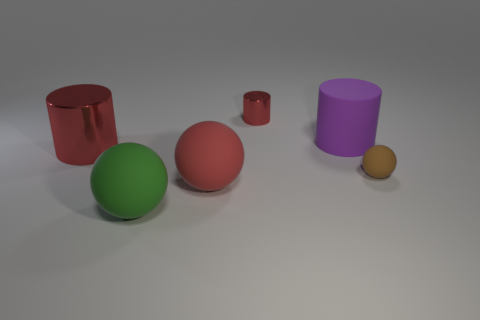How big is the matte cylinder?
Your answer should be compact. Large. How many things are either small blue metal cylinders or rubber objects?
Your response must be concise. 4. Are the big red thing that is in front of the big red metal cylinder and the sphere right of the big matte cylinder made of the same material?
Keep it short and to the point. Yes. There is a big cylinder that is the same material as the small cylinder; what color is it?
Make the answer very short. Red. What number of other balls have the same size as the green matte sphere?
Your answer should be very brief. 1. What number of other things are there of the same color as the tiny metallic cylinder?
Give a very brief answer. 2. Is there anything else that is the same size as the brown sphere?
Provide a short and direct response. Yes. There is a large rubber object behind the tiny matte sphere; does it have the same shape as the small object left of the small brown rubber ball?
Your response must be concise. Yes. There is a red rubber object that is the same size as the purple rubber thing; what shape is it?
Offer a terse response. Sphere. Are there an equal number of shiny cylinders in front of the big red rubber ball and large purple objects that are to the right of the brown matte thing?
Give a very brief answer. Yes. 